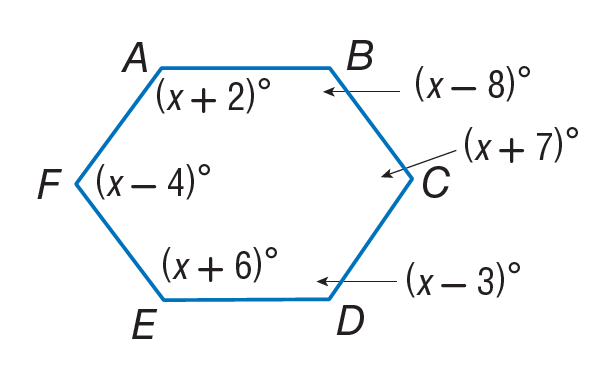Answer the mathemtical geometry problem and directly provide the correct option letter.
Question: Find m \angle E.
Choices: A: 56 B: 80 C: 126 D: 130 C 